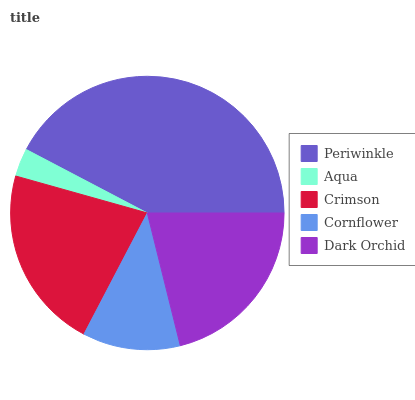Is Aqua the minimum?
Answer yes or no. Yes. Is Periwinkle the maximum?
Answer yes or no. Yes. Is Crimson the minimum?
Answer yes or no. No. Is Crimson the maximum?
Answer yes or no. No. Is Crimson greater than Aqua?
Answer yes or no. Yes. Is Aqua less than Crimson?
Answer yes or no. Yes. Is Aqua greater than Crimson?
Answer yes or no. No. Is Crimson less than Aqua?
Answer yes or no. No. Is Dark Orchid the high median?
Answer yes or no. Yes. Is Dark Orchid the low median?
Answer yes or no. Yes. Is Aqua the high median?
Answer yes or no. No. Is Cornflower the low median?
Answer yes or no. No. 